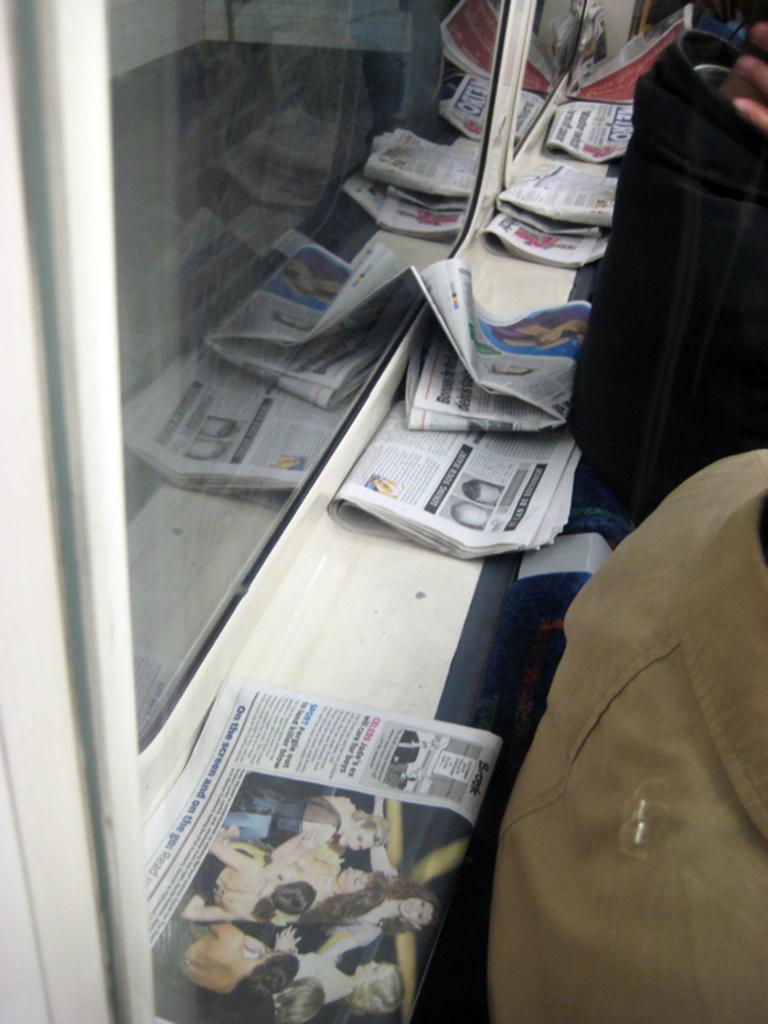Please provide a concise description of this image. In this image I can see on the left side there are glass walls. In the middle there are newspapers. On the right side it looks like there are two persons, at the bottom there are girls in the newspaper. 